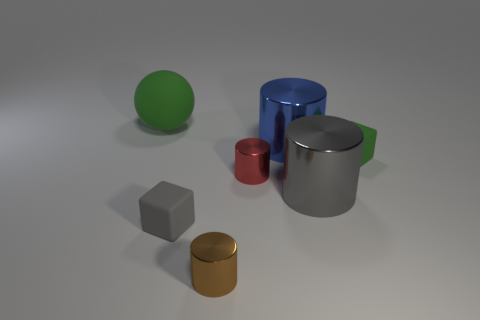What objects are visible in this image, and can you describe their colors? The image shows a collection of objects including a large blue cylinder, a small red cylinder, a green sphere, a grey cube, a silver cylinder, and a small gold cylinder. They're all placed on a flat surface with a neutral background. 